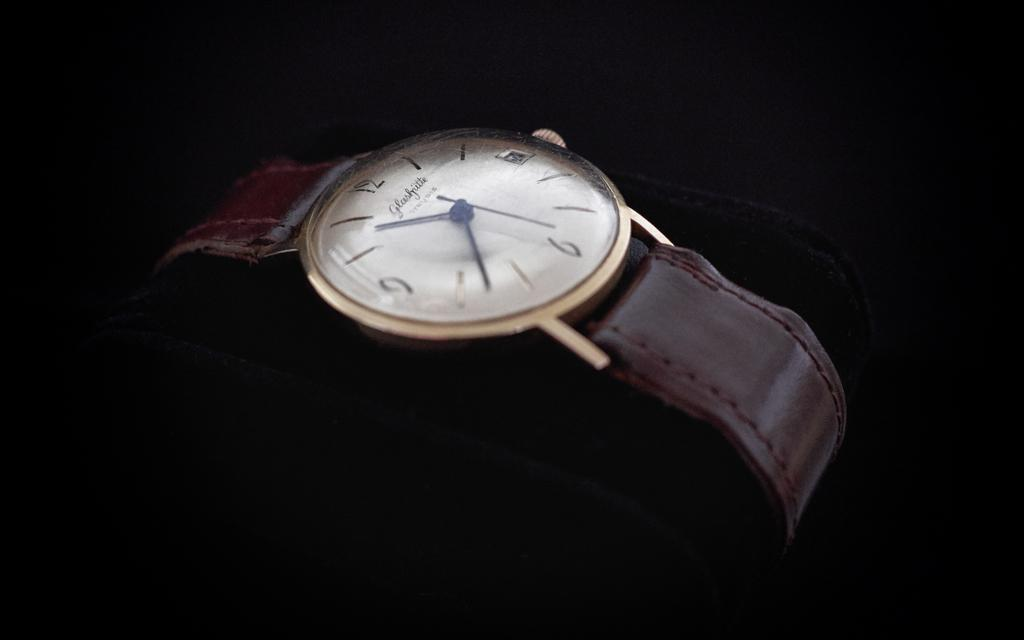What object is the main focus of the image? There is a watch in the image. What color is the background of the image? The background of the image is black. What direction is the police officer facing in the image? There is no police officer present in the image; it only features a watch with a black background. What type of boot is visible in the image? There is no boot present in the image; it only features a watch with a black background. 